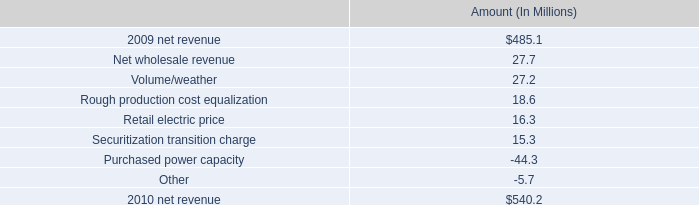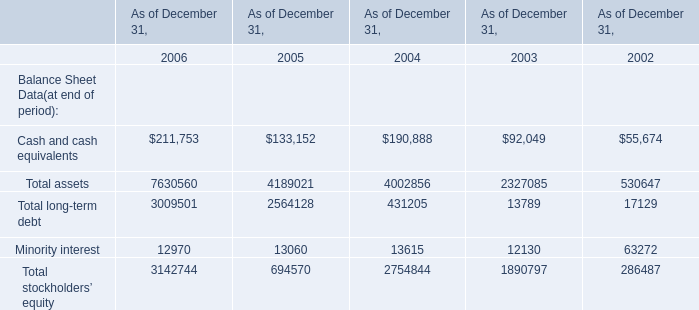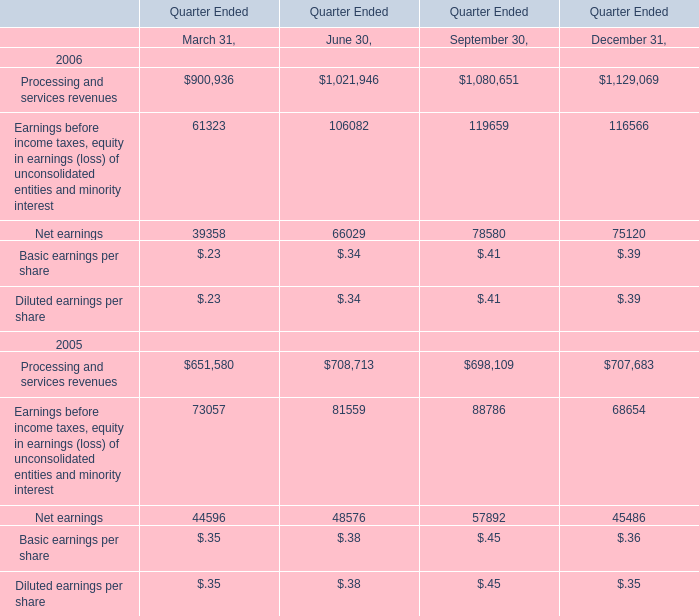What was the sum of Cash and cash equivalents without those Total assets smaller than 7000000 in 2006? 
Answer: 211753. 